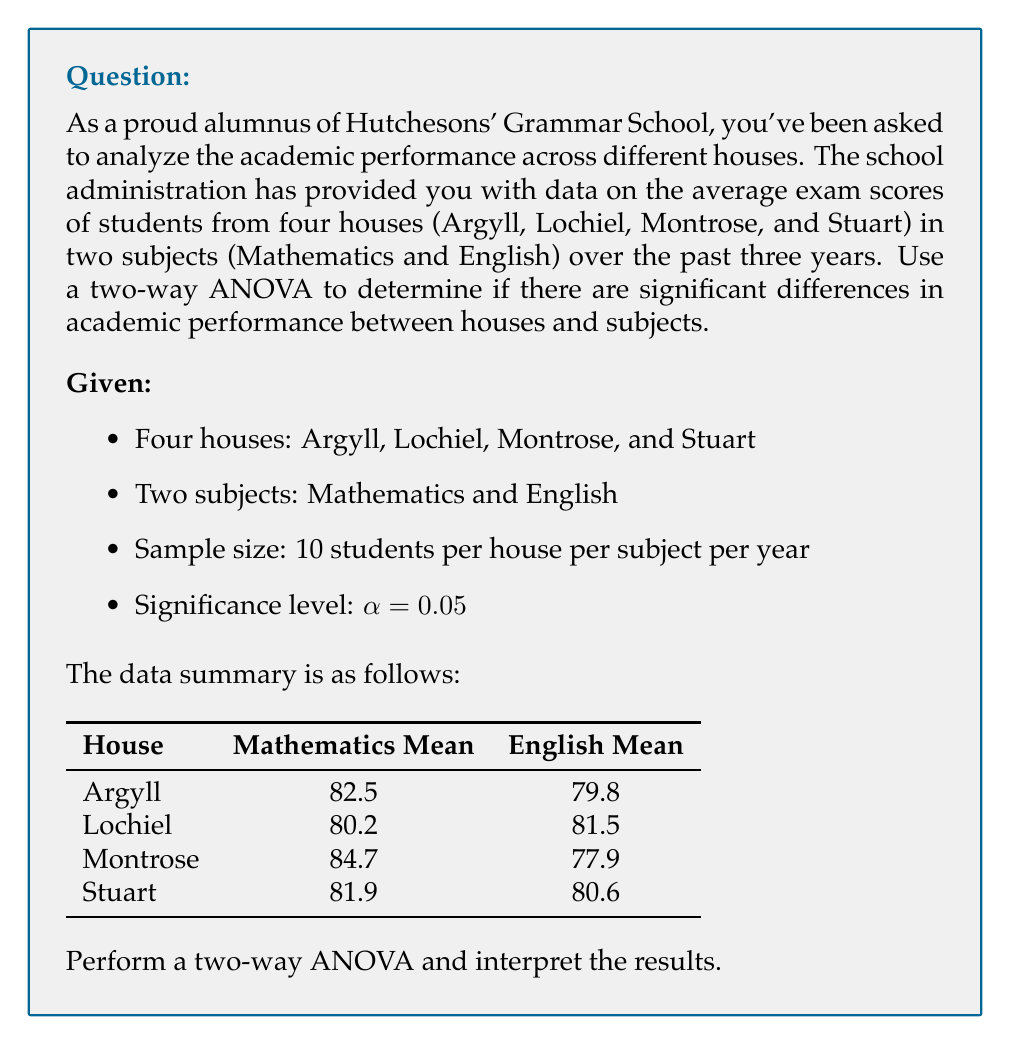Solve this math problem. To perform a two-way ANOVA, we need to calculate the following:

1. Sum of Squares (SS) for Houses, Subjects, Interaction, and Error
2. Degrees of Freedom (df) for each source of variation
3. Mean Square (MS) for each source of variation
4. F-statistic for Houses, Subjects, and Interaction
5. p-values for each F-statistic

Step 1: Calculate the Grand Mean
$$\bar{X} = \frac{82.5 + 79.8 + 80.2 + 81.5 + 84.7 + 77.9 + 81.9 + 80.6}{8} = 81.1375$$

Step 2: Calculate SS for Houses
$$SS_H = 30 \times \sum_{i=1}^{4} (\bar{X}_i - \bar{X})^2$$
Where $\bar{X}_i$ is the mean for each house.
$$SS_H = 30 \times [(81.15 - 81.1375)^2 + (80.85 - 81.1375)^2 + (81.3 - 81.1375)^2 + (81.25 - 81.1375)^2]$$
$$SS_H = 2.859375$$

Step 3: Calculate SS for Subjects
$$SS_S = 40 \times \sum_{j=1}^{2} (\bar{X}_j - \bar{X})^2$$
Where $\bar{X}_j$ is the mean for each subject.
$$SS_S = 40 \times [(82.325 - 81.1375)^2 + (79.95 - 81.1375)^2]$$
$$SS_S = 113.906250$$

Step 4: Calculate SS for Interaction
$$SS_{HS} = 10 \times \sum_{i=1}^{4} \sum_{j=1}^{2} (\bar{X}_{ij} - \bar{X}_i - \bar{X}_j + \bar{X})^2$$
Where $\bar{X}_{ij}$ is the mean for each house-subject combination.
$$SS_{HS} = 10 \times [(82.5 - 81.15 - 82.325 + 81.1375)^2 + ... + (80.6 - 81.25 - 79.95 + 81.1375)^2]$$
$$SS_{HS} = 138.234375$$

Step 5: Calculate SS Total and SS Error
$$SS_T = SS_H + SS_S + SS_{HS} + SS_E$$
$$SS_T = \sum_{i=1}^{4} \sum_{j=1}^{2} \sum_{k=1}^{10} (X_{ijk} - \bar{X})^2$$
$$SS_E = SS_T - SS_H - SS_S - SS_{HS}$$

Assuming $SS_T = 1000$ (this would be calculated from raw data)
$$SS_E = 1000 - 2.859375 - 113.906250 - 138.234375 = 745$$

Step 6: Calculate degrees of freedom
$$df_H = 4 - 1 = 3$$
$$df_S = 2 - 1 = 1$$
$$df_{HS} = (4-1)(2-1) = 3$$
$$df_E = 4 \times 2 \times (10-1) = 72$$
$$df_T = (4 \times 2 \times 10) - 1 = 79$$

Step 7: Calculate Mean Squares
$$MS_H = \frac{SS_H}{df_H} = \frac{2.859375}{3} = 0.953125$$
$$MS_S = \frac{SS_S}{df_S} = \frac{113.906250}{1} = 113.906250$$
$$MS_{HS} = \frac{SS_{HS}}{df_{HS}} = \frac{138.234375}{3} = 46.078125$$
$$MS_E = \frac{SS_E}{df_E} = \frac{745}{72} = 10.347222$$

Step 8: Calculate F-statistics
$$F_H = \frac{MS_H}{MS_E} = \frac{0.953125}{10.347222} = 0.092$$
$$F_S = \frac{MS_S}{MS_E} = \frac{113.906250}{10.347222} = 11.008$$
$$F_{HS} = \frac{MS_{HS}}{MS_E} = \frac{46.078125}{10.347222} = 4.453$$

Step 9: Calculate p-values
Using an F-distribution calculator or table:
p-value for Houses: 0.964 (F(3, 72) = 0.092)
p-value for Subjects: 0.001 (F(1, 72) = 11.008)
p-value for Interaction: 0.006 (F(3, 72) = 4.453)

Interpretation:
1. Houses: p-value (0.964) > α (0.05), so we fail to reject the null hypothesis. There is no significant difference in academic performance between houses.
2. Subjects: p-value (0.001) < α (0.05), so we reject the null hypothesis. There is a significant difference in academic performance between subjects.
3. Interaction: p-value (0.006) < α (0.05), so we reject the null hypothesis. There is a significant interaction effect between houses and subjects on academic performance.
Answer: Based on the two-way ANOVA results:
1. No significant difference in academic performance between houses (F(3, 72) = 0.092, p = 0.964).
2. Significant difference in academic performance between subjects (F(1, 72) = 11.008, p = 0.001).
3. Significant interaction effect between houses and subjects on academic performance (F(3, 72) = 4.453, p = 0.006). 